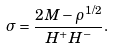<formula> <loc_0><loc_0><loc_500><loc_500>\sigma = \frac { 2 M - \rho ^ { 1 / 2 } } { H ^ { + } H ^ { - } } .</formula> 